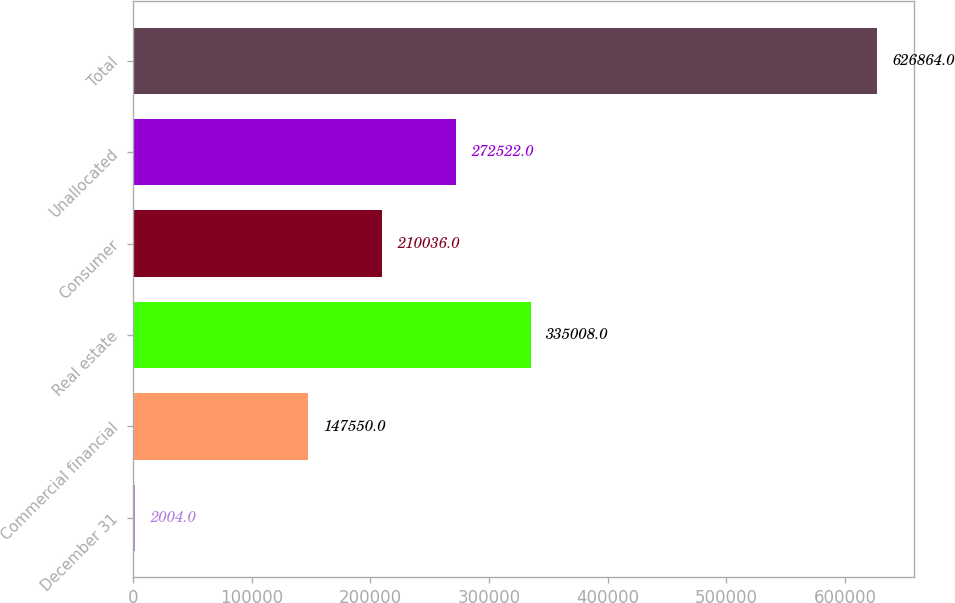<chart> <loc_0><loc_0><loc_500><loc_500><bar_chart><fcel>December 31<fcel>Commercial financial<fcel>Real estate<fcel>Consumer<fcel>Unallocated<fcel>Total<nl><fcel>2004<fcel>147550<fcel>335008<fcel>210036<fcel>272522<fcel>626864<nl></chart> 